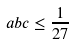<formula> <loc_0><loc_0><loc_500><loc_500>a b c \leq \frac { 1 } { 2 7 }</formula> 